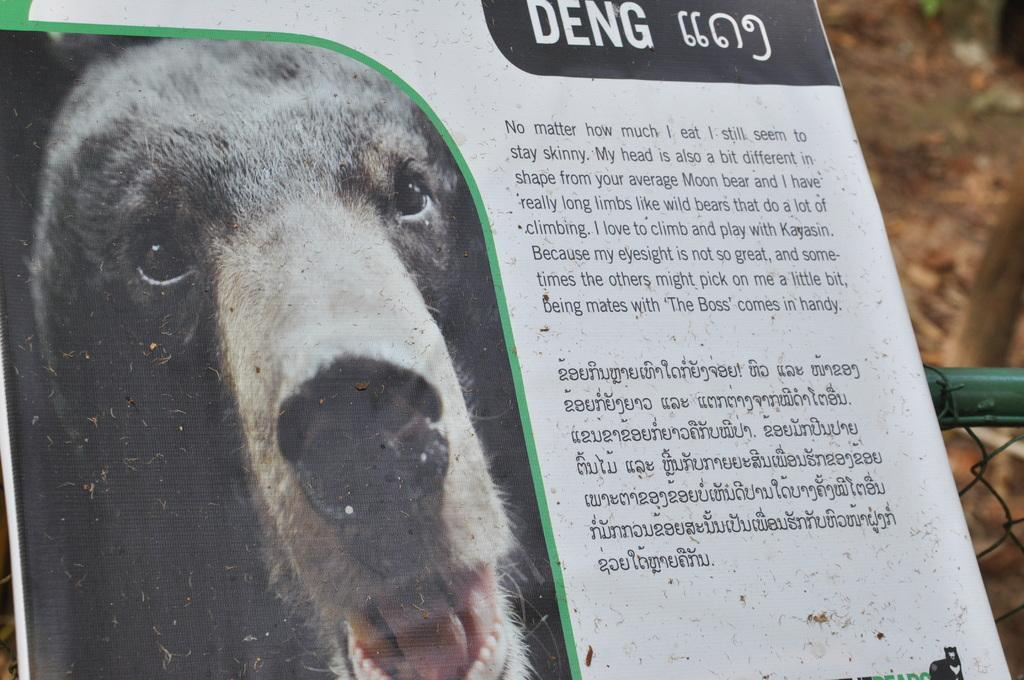What is located in the middle of the image? There is a poster in the middle of the image. What type of image is on the poster? The poster has an image of an animal. What else is featured on the poster besides the image? There is text on the poster. What can be seen in the background of the image? There is a ground and a fence visible in the background of the image. What type of train can be seen passing by in the image? There is no train present in the image; it only features a poster with an animal image and text, along with a ground and a fence in the background. How many hens are visible on the poster? There is no hen present on the poster; it has an image of an animal, but it is not specified as a hen. 